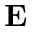Convert formula to latex. <formula><loc_0><loc_0><loc_500><loc_500>{ E }</formula> 